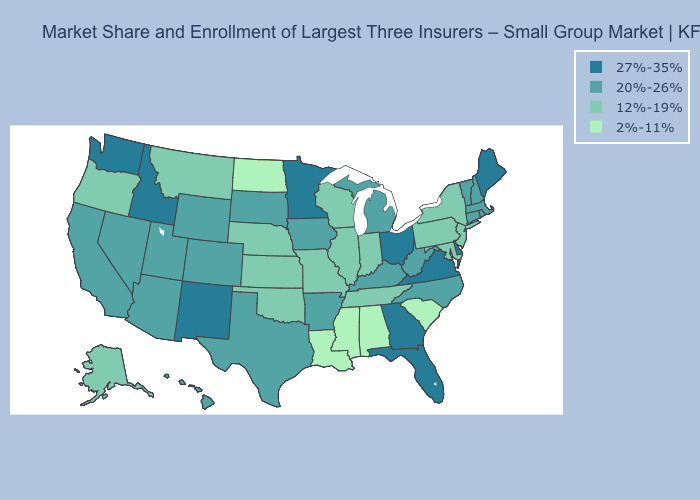Which states have the highest value in the USA?
Quick response, please. Delaware, Florida, Georgia, Idaho, Maine, Minnesota, New Mexico, Ohio, Virginia, Washington. Does New Mexico have the highest value in the West?
Be succinct. Yes. What is the lowest value in the MidWest?
Concise answer only. 2%-11%. Does the map have missing data?
Concise answer only. No. Which states have the lowest value in the MidWest?
Concise answer only. North Dakota. Which states have the highest value in the USA?
Answer briefly. Delaware, Florida, Georgia, Idaho, Maine, Minnesota, New Mexico, Ohio, Virginia, Washington. Among the states that border Colorado , which have the lowest value?
Write a very short answer. Kansas, Nebraska, Oklahoma. Does Georgia have the lowest value in the USA?
Short answer required. No. Name the states that have a value in the range 12%-19%?
Answer briefly. Alaska, Illinois, Indiana, Kansas, Maryland, Missouri, Montana, Nebraska, New Jersey, New York, Oklahoma, Oregon, Pennsylvania, Tennessee, Wisconsin. Name the states that have a value in the range 12%-19%?
Concise answer only. Alaska, Illinois, Indiana, Kansas, Maryland, Missouri, Montana, Nebraska, New Jersey, New York, Oklahoma, Oregon, Pennsylvania, Tennessee, Wisconsin. What is the highest value in the USA?
Quick response, please. 27%-35%. Does Rhode Island have a lower value than Wisconsin?
Short answer required. No. How many symbols are there in the legend?
Give a very brief answer. 4. What is the value of Kentucky?
Answer briefly. 20%-26%. 